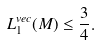Convert formula to latex. <formula><loc_0><loc_0><loc_500><loc_500>L _ { 1 } ^ { v e c } ( M ) \leq \frac { 3 } { 4 } .</formula> 